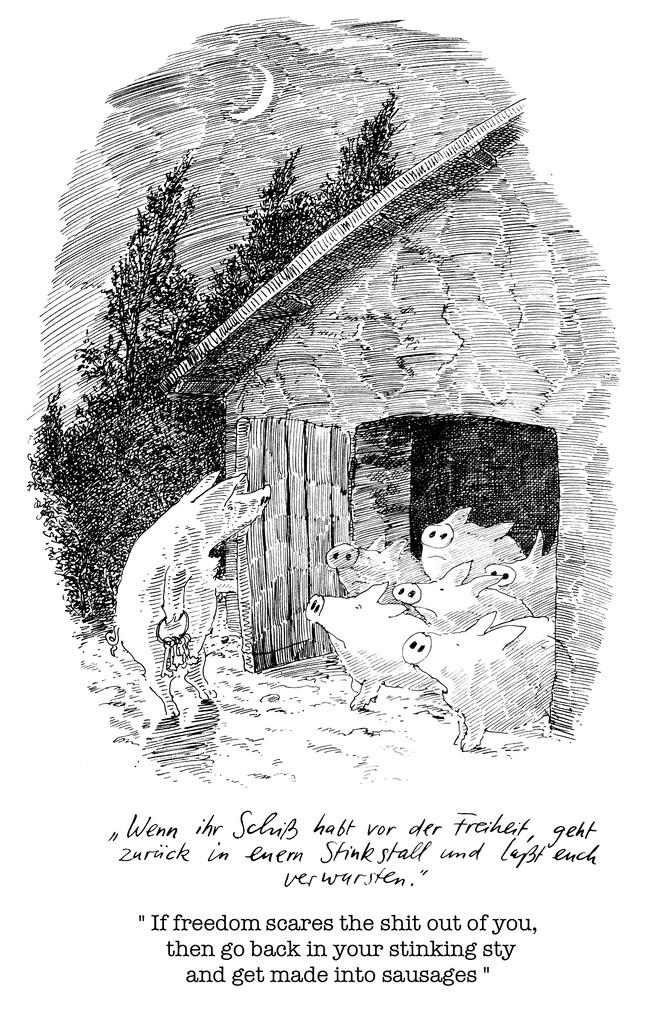What is depicted in the art of the image? The image contains an art of a hut. Are there any animals present in the image? Yes, there are pigs in the image. What type of vegetation can be seen in the image? There are trees in the image. What celestial body is visible in the image? The moon is visible in the image. What is written at the bottom of the image? There is text at the bottom of the image. What color is the background of the image? The background of the image is white. What type of sign can be seen in the image? There is no sign present in the image. Can you tell me how many frogs are depicted in the image? There are no frogs depicted in the image. 